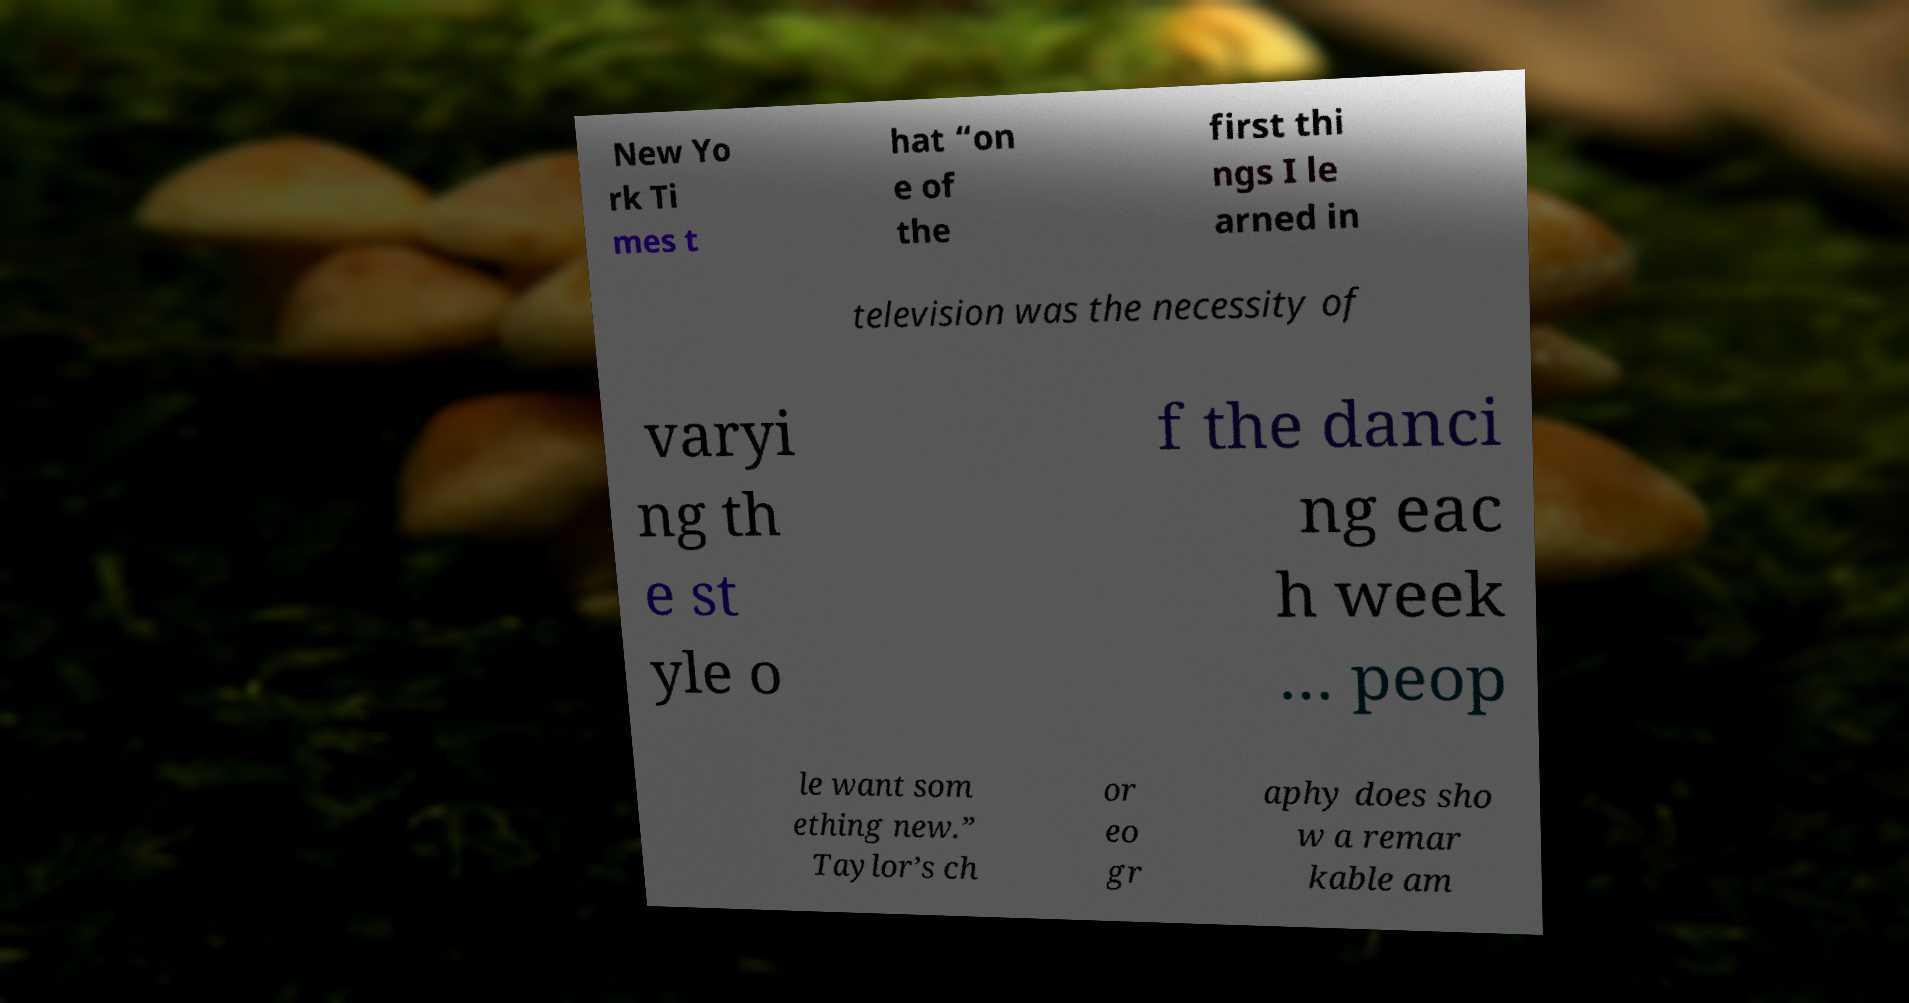Can you read and provide the text displayed in the image?This photo seems to have some interesting text. Can you extract and type it out for me? New Yo rk Ti mes t hat “on e of the first thi ngs I le arned in television was the necessity of varyi ng th e st yle o f the danci ng eac h week … peop le want som ething new.” Taylor’s ch or eo gr aphy does sho w a remar kable am 